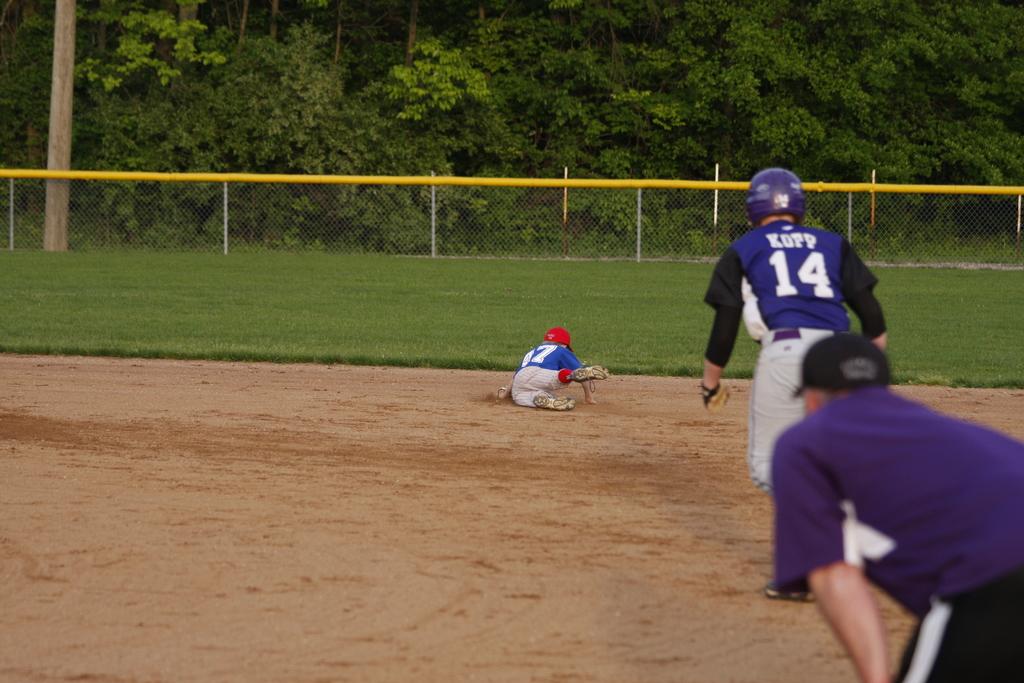What is the blue player that is standings number?
Your response must be concise. 14. 